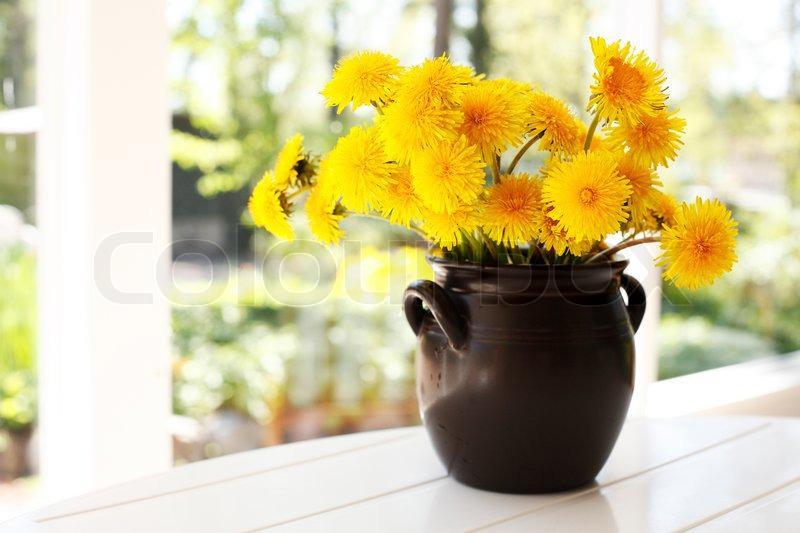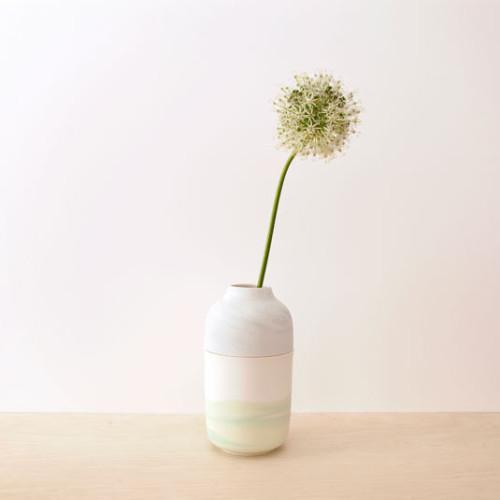The first image is the image on the left, the second image is the image on the right. Analyze the images presented: Is the assertion "The white vase is filled with yellow flowers." valid? Answer yes or no. No. 